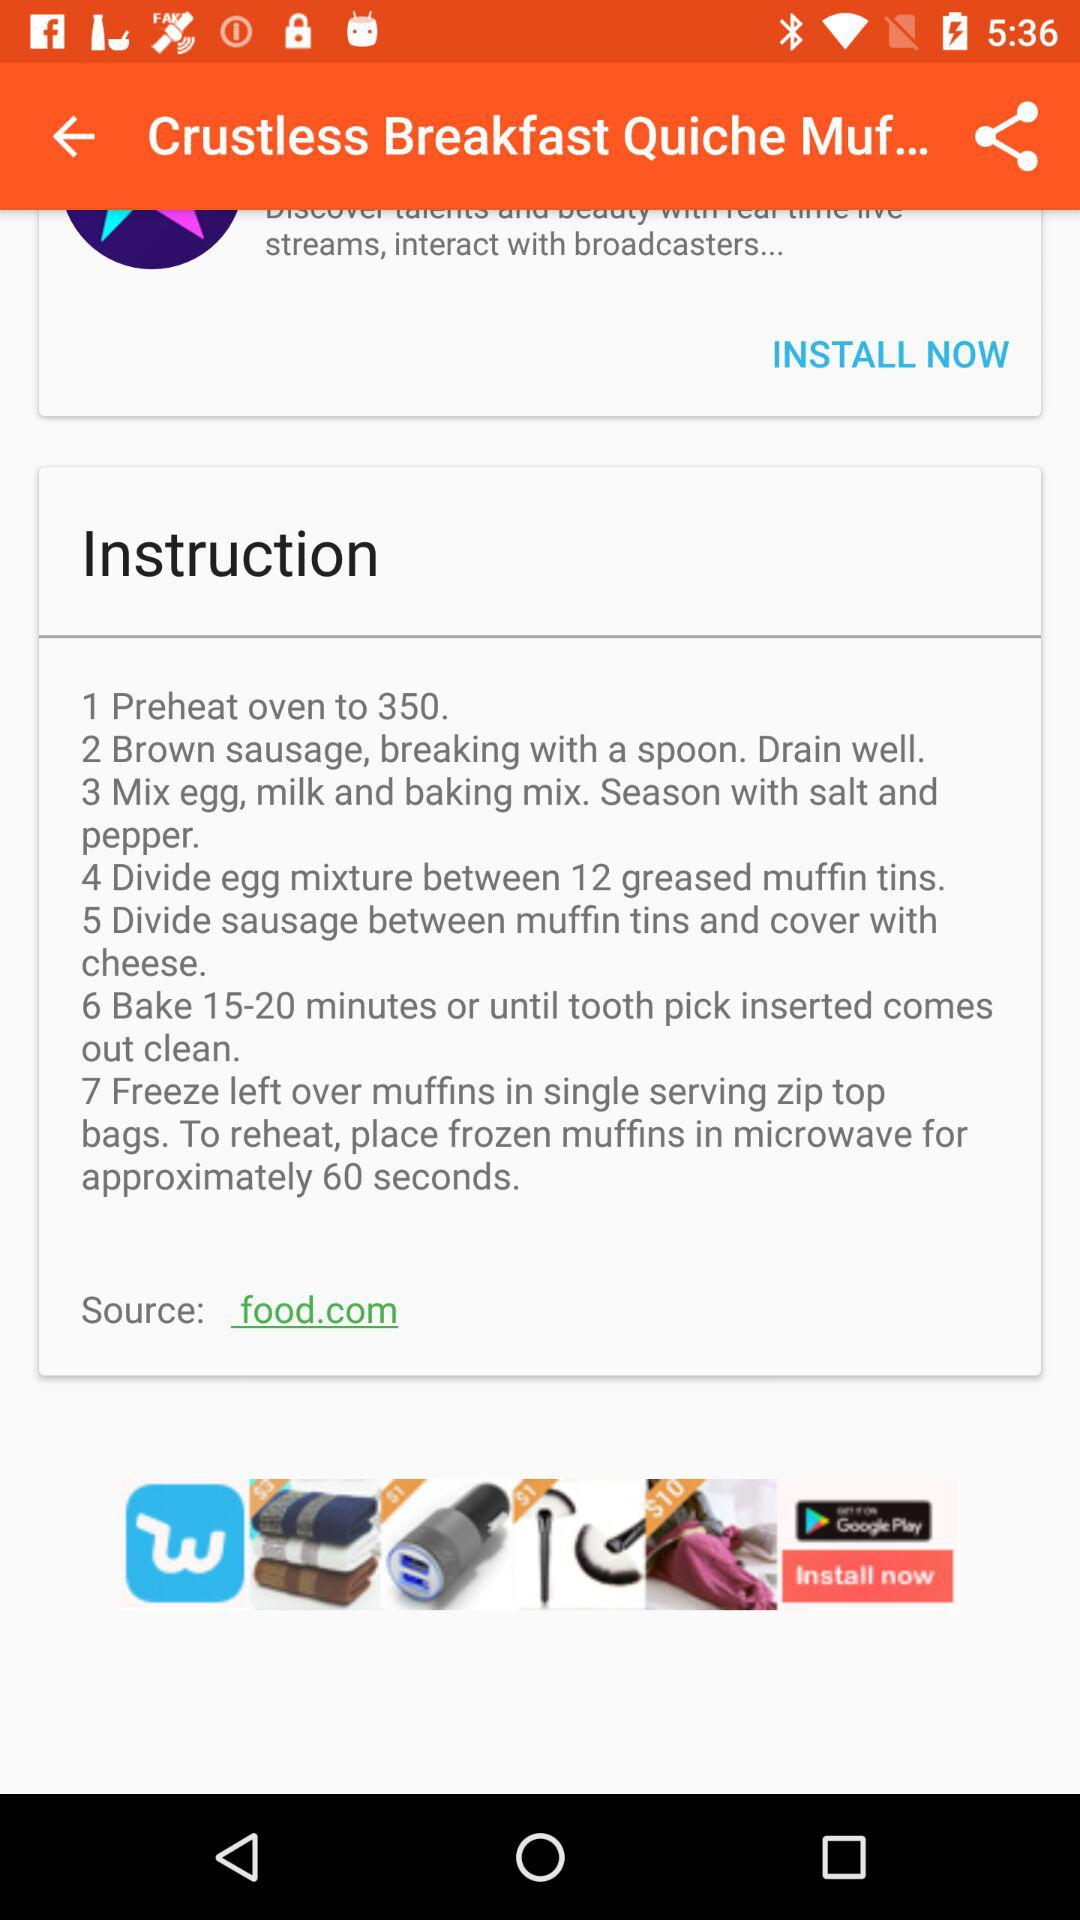How many steps are there in total?
Answer the question using a single word or phrase. 7 